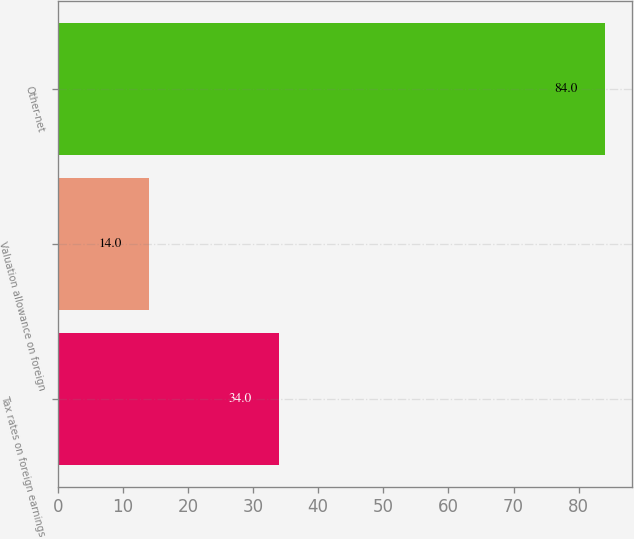Convert chart. <chart><loc_0><loc_0><loc_500><loc_500><bar_chart><fcel>Tax rates on foreign earnings<fcel>Valuation allowance on foreign<fcel>Other-net<nl><fcel>34<fcel>14<fcel>84<nl></chart> 